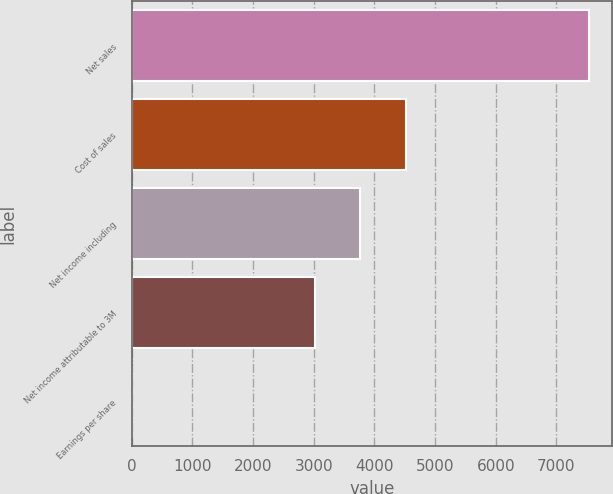Convert chart. <chart><loc_0><loc_0><loc_500><loc_500><bar_chart><fcel>Net sales<fcel>Cost of sales<fcel>Net income including<fcel>Net income attributable to 3M<fcel>Earnings per share<nl><fcel>7534<fcel>4521.04<fcel>3767.8<fcel>3014.56<fcel>1.6<nl></chart> 